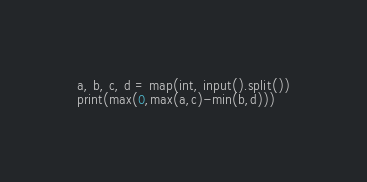<code> <loc_0><loc_0><loc_500><loc_500><_Python_>a, b, c, d = map(int, input().split())
print(max(0,max(a,c)-min(b,d)))</code> 